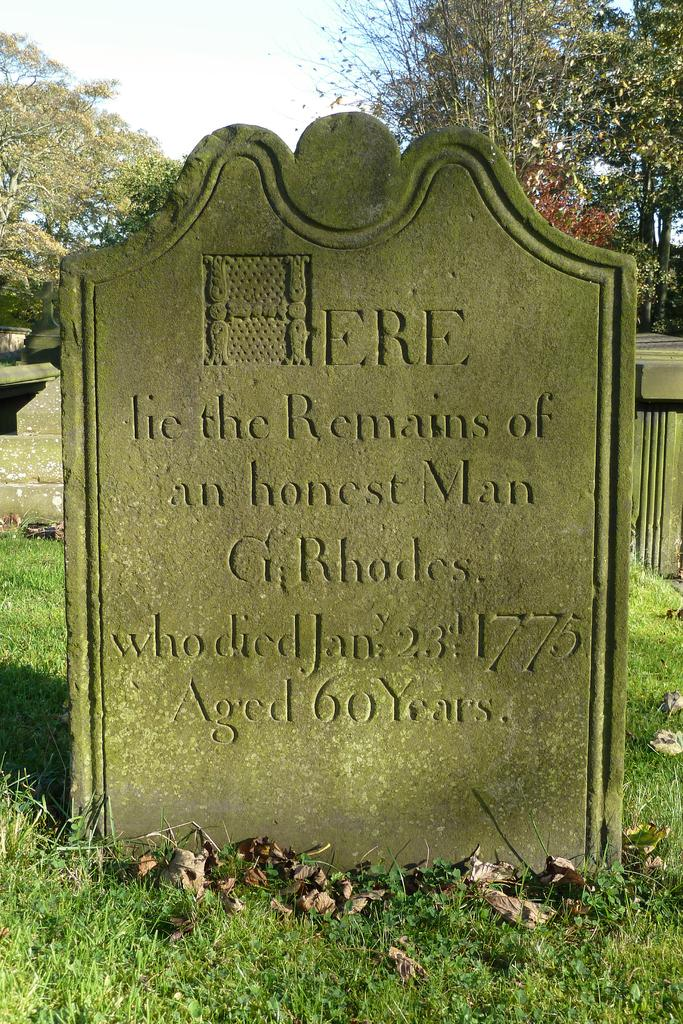What is the main subject of the image? The main subject of the image is a graveyard. Are there any other elements in the background of the image? Yes, there are trees behind the graveyard. What type of eggs can be seen in the image? There are no eggs present in the image; it features a graveyard and trees. What subject is being taught in the image? There is no teaching activity depicted in the image; it shows a graveyard and trees. 